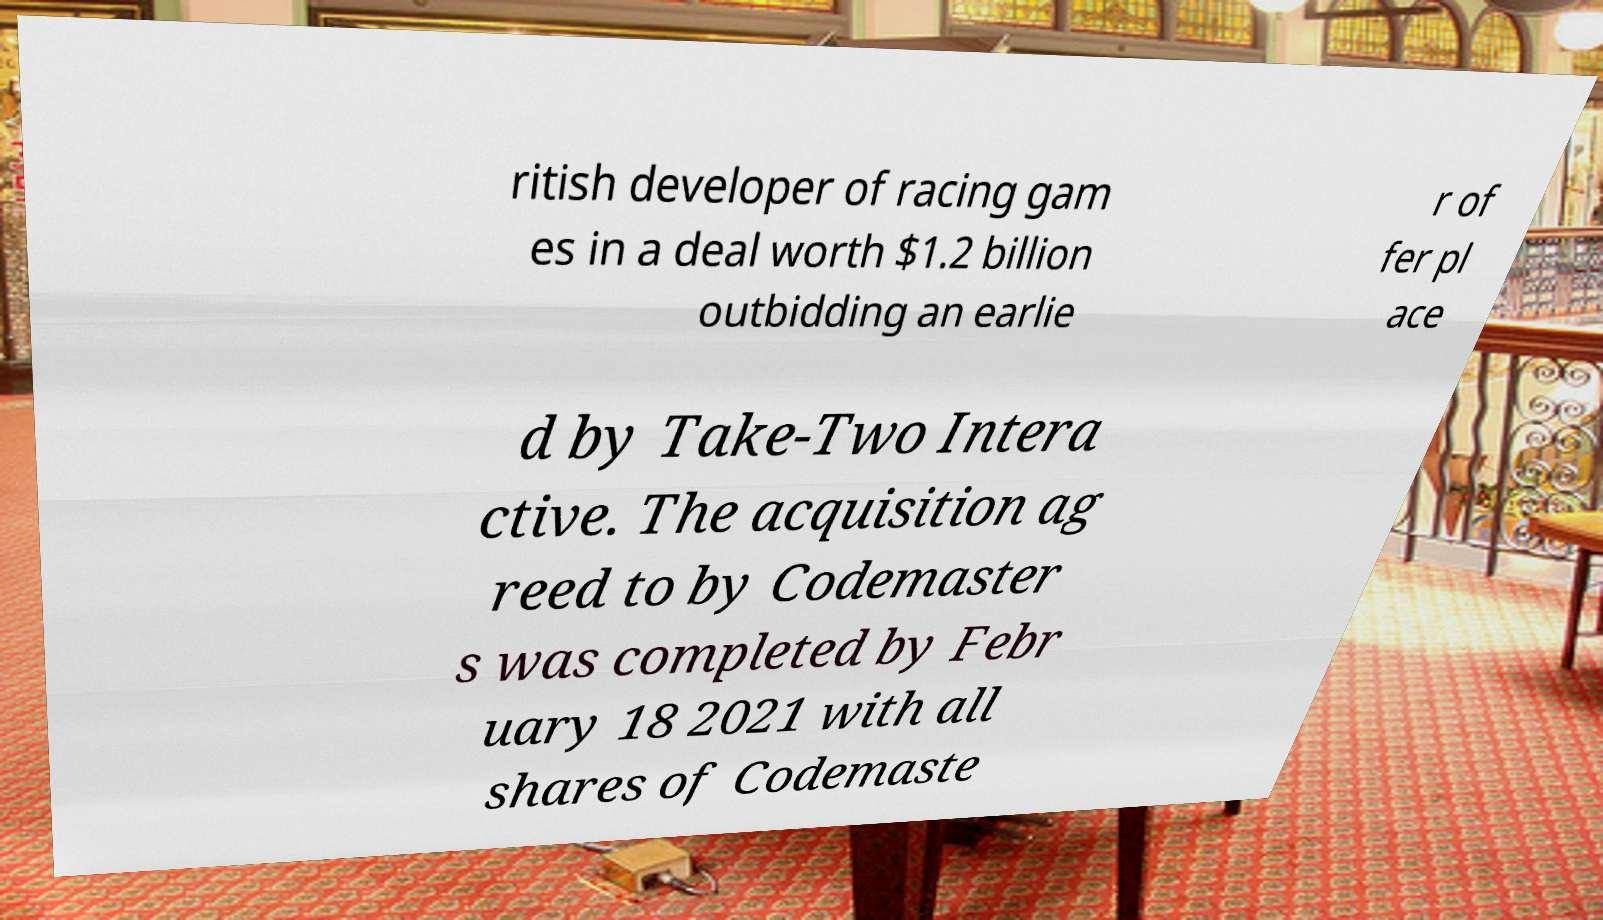Can you accurately transcribe the text from the provided image for me? ritish developer of racing gam es in a deal worth $1.2 billion outbidding an earlie r of fer pl ace d by Take-Two Intera ctive. The acquisition ag reed to by Codemaster s was completed by Febr uary 18 2021 with all shares of Codemaste 